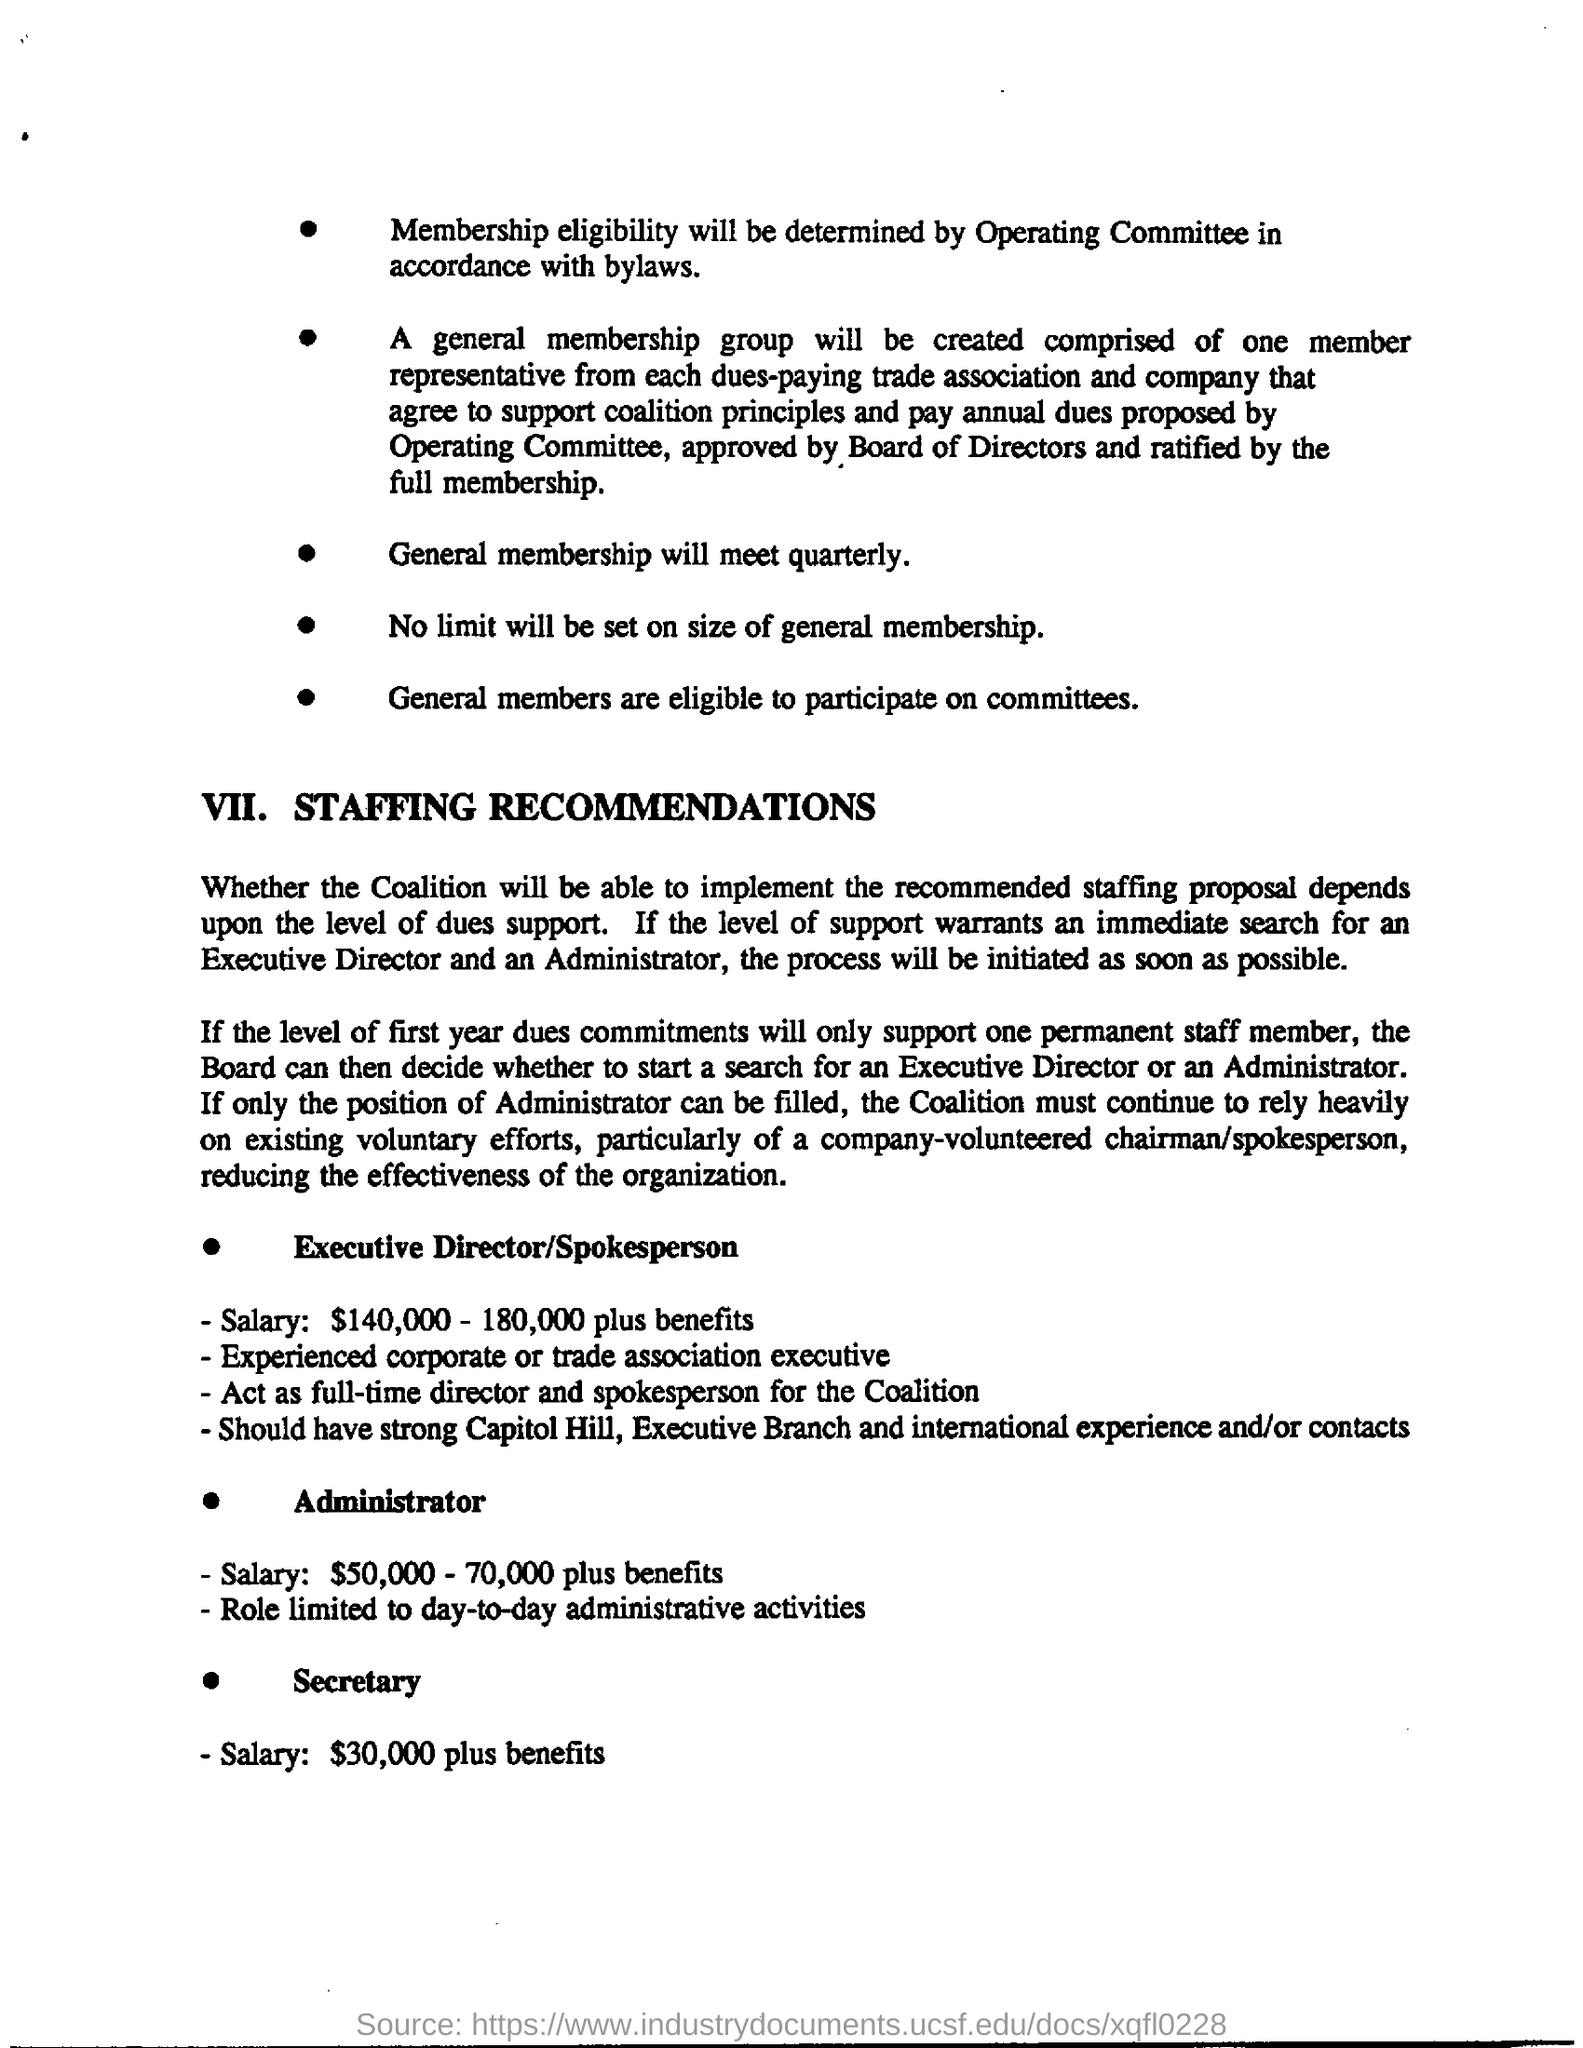Draw attention to some important aspects in this diagram. The general membership will hold quarterly meetings. The administrator's role is limited to performing only day-to-day administrative tasks. There is no limit on the size of general membership. The Operating Committee, in accordance with the bylaws, will determine the membership eligibility. The Executive Director/Spokesperson typically receives the highest salary and benefits among all employees. 